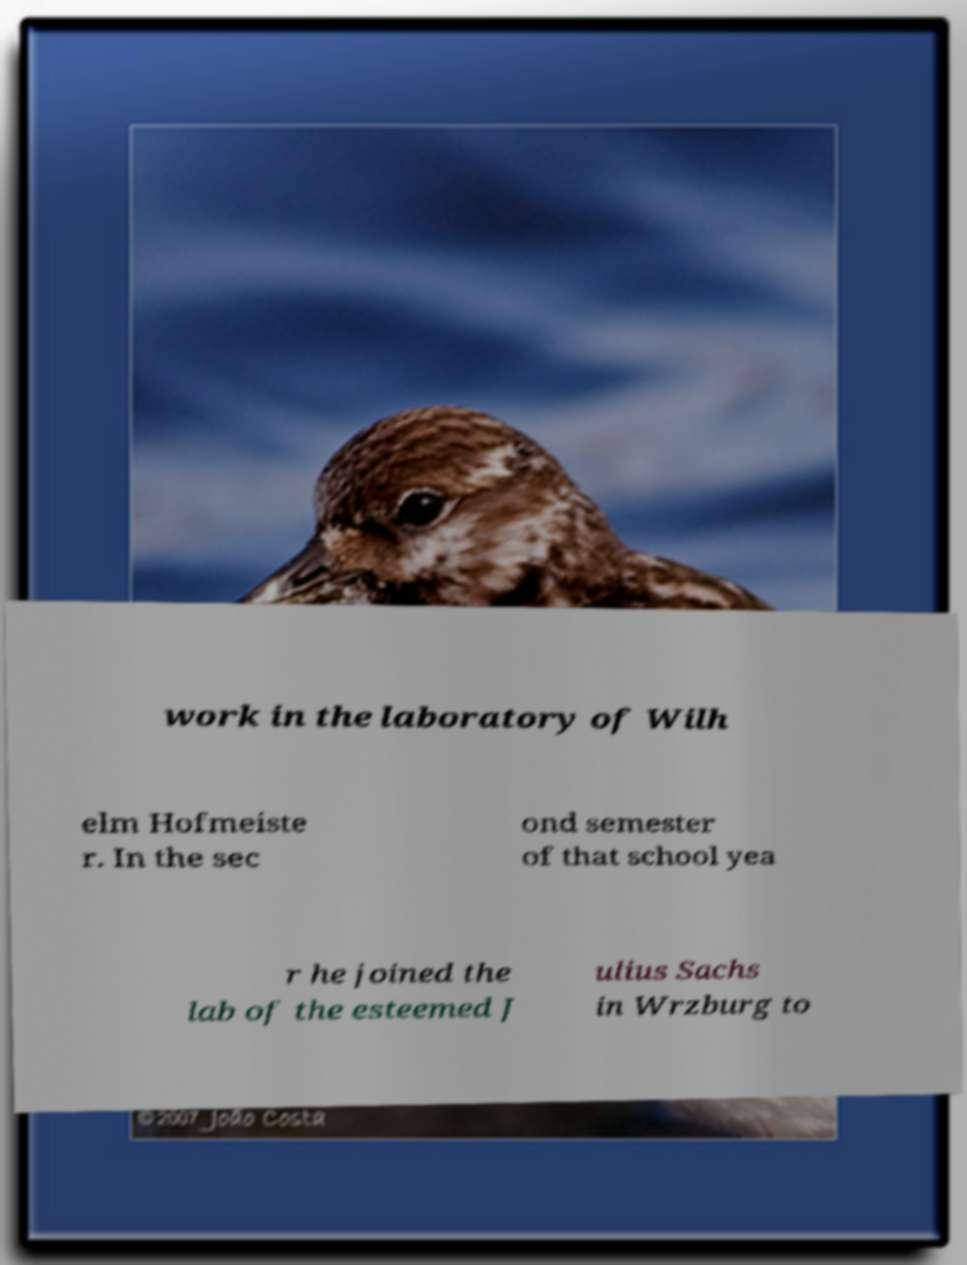For documentation purposes, I need the text within this image transcribed. Could you provide that? work in the laboratory of Wilh elm Hofmeiste r. In the sec ond semester of that school yea r he joined the lab of the esteemed J ulius Sachs in Wrzburg to 